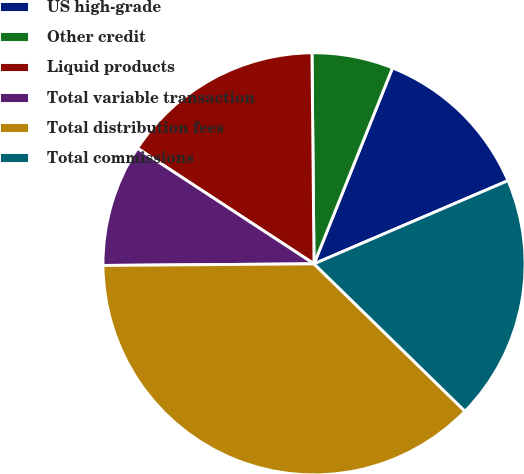Convert chart. <chart><loc_0><loc_0><loc_500><loc_500><pie_chart><fcel>US high-grade<fcel>Other credit<fcel>Liquid products<fcel>Total variable transaction<fcel>Total distribution fees<fcel>Total commissions<nl><fcel>12.49%<fcel>6.22%<fcel>15.62%<fcel>9.35%<fcel>37.57%<fcel>18.76%<nl></chart> 